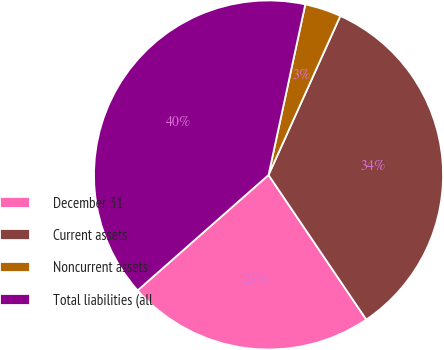Convert chart. <chart><loc_0><loc_0><loc_500><loc_500><pie_chart><fcel>December 31<fcel>Current assets<fcel>Noncurrent assets<fcel>Total liabilities (all<nl><fcel>22.96%<fcel>33.79%<fcel>3.37%<fcel>39.88%<nl></chart> 